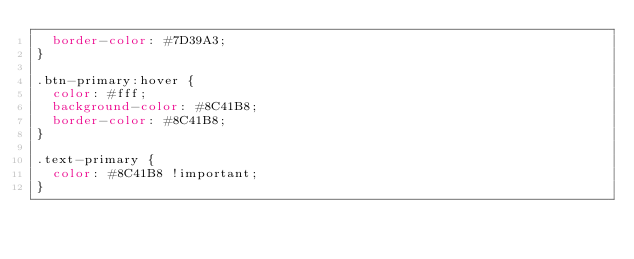Convert code to text. <code><loc_0><loc_0><loc_500><loc_500><_CSS_>  border-color: #7D39A3;
}

.btn-primary:hover {
  color: #fff;
  background-color: #8C41B8;
  border-color: #8C41B8;
}

.text-primary {
  color: #8C41B8 !important;
}
</code> 